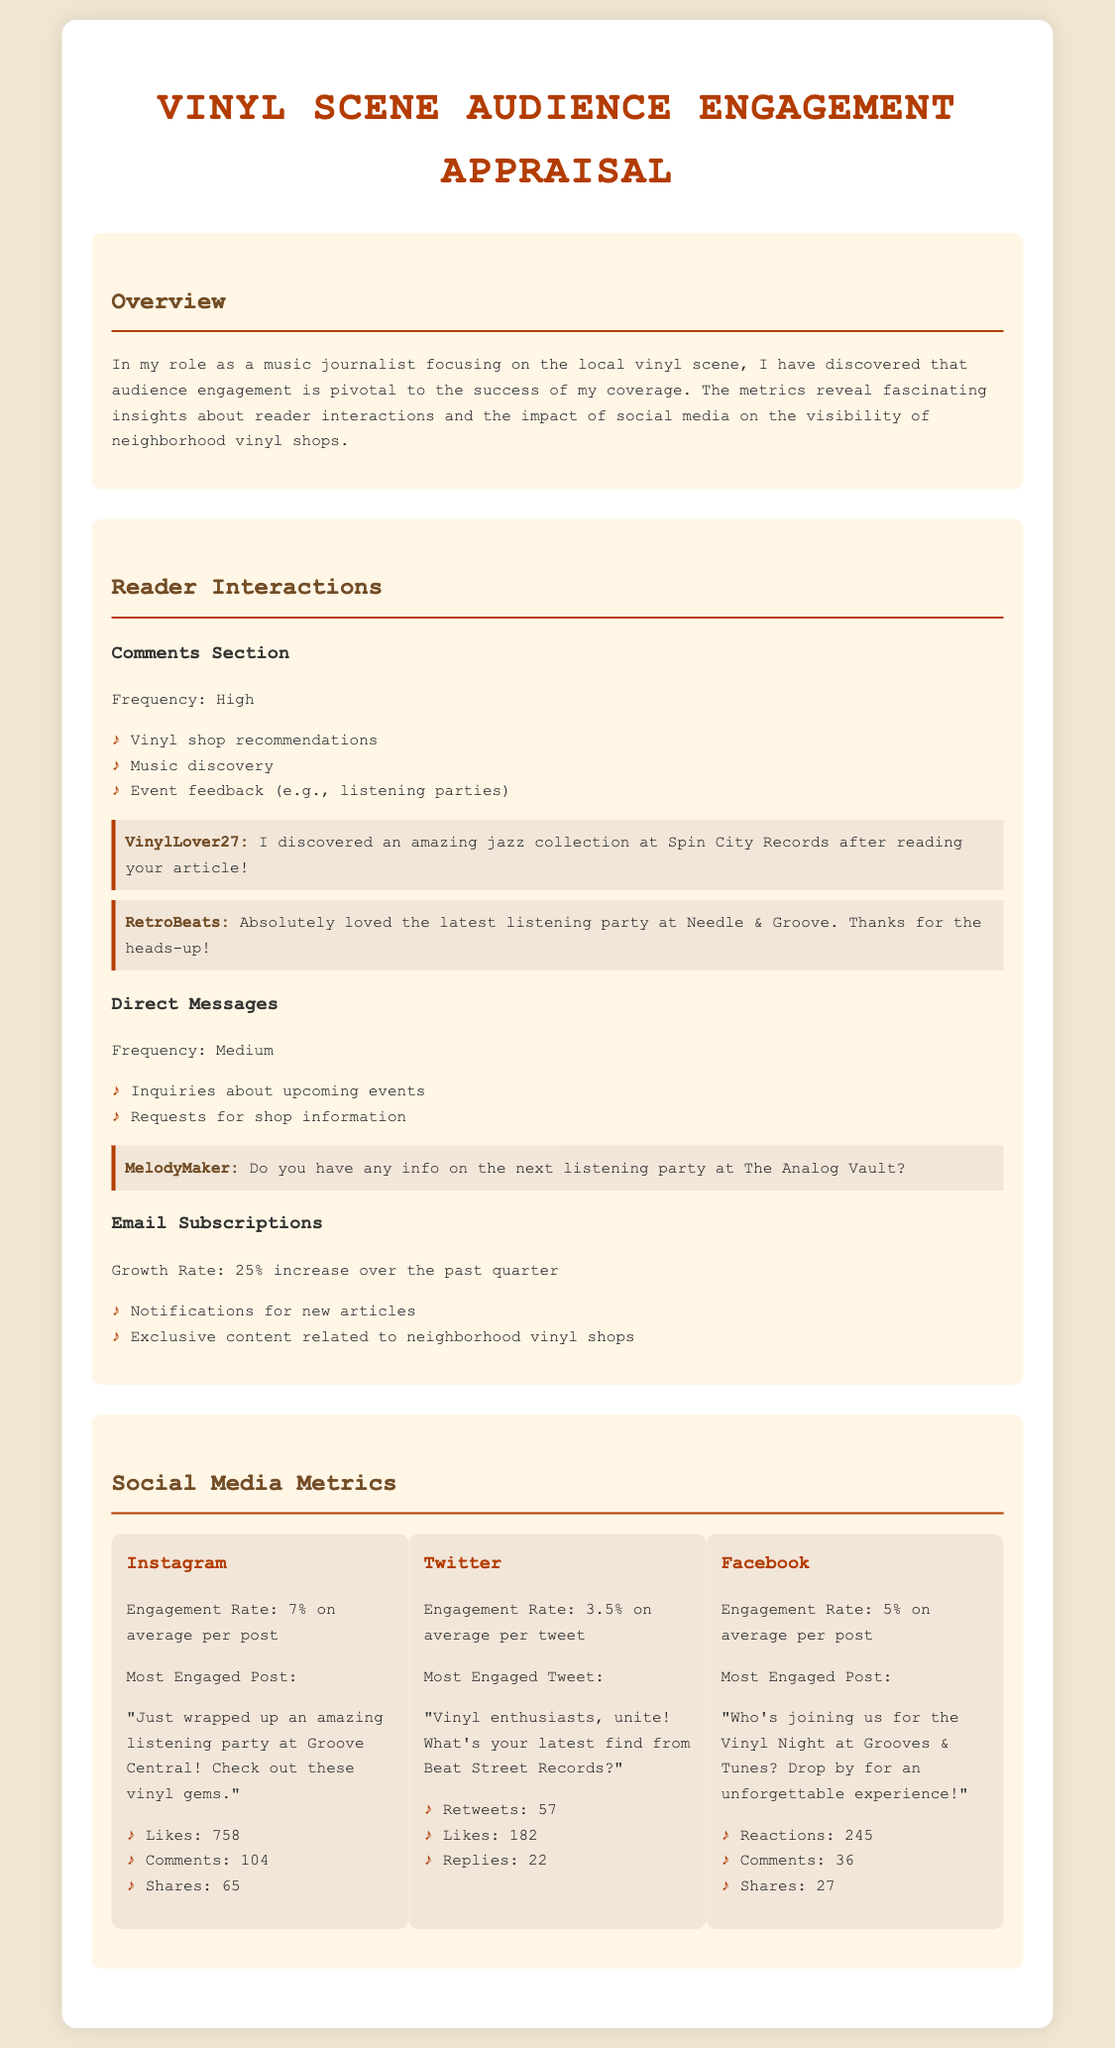what is the engagement rate for Instagram? The engagement rate for Instagram is listed in the document as 7%.
Answer: 7% how much did email subscriptions grow over the past quarter? The document specifies a 25% increase in email subscriptions over the past quarter.
Answer: 25% who is the user that loved the listening party at Needle & Groove? The comment reveals that the user who expressed love for the listening party at Needle & Groove is RetroBeats.
Answer: RetroBeats what are the most engaged post metrics on Facebook? The document lists the metrics for the most engaged Facebook post: 245 reactions, 36 comments, and 27 shares.
Answer: 245 reactions, 36 comments, 27 shares what type of feedback do readers commonly provide in comments? The document summarizes common feedback types in comments as vinyl shop recommendations, music discovery, and event feedback.
Answer: Vinyl shop recommendations, music discovery, event feedback what was the most engaged post on Instagram about? The most engaged post on Instagram discussed an amazing listening party at Groove Central.
Answer: An amazing listening party at Groove Central how many likes did the most engaged tweet receive? The document states that the most engaged tweet received 182 likes.
Answer: 182 what is the frequency of direct messages? The frequency of direct messages is described in the document as medium.
Answer: Medium which platform has the highest average engagement rate? The engagement rates provided indicate that Instagram has the highest average engagement rate at 7%.
Answer: Instagram 